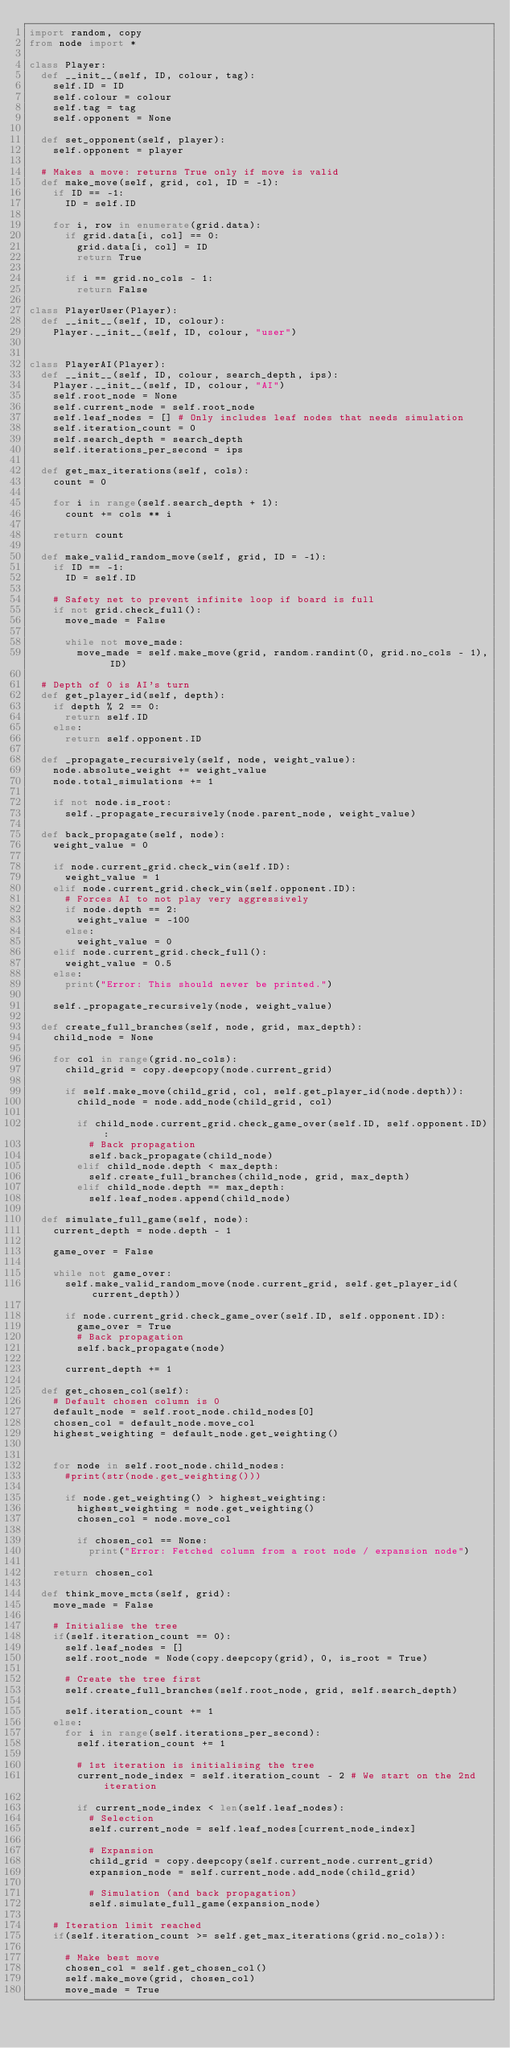<code> <loc_0><loc_0><loc_500><loc_500><_Python_>import random, copy
from node import *

class Player:
	def __init__(self, ID, colour, tag):
		self.ID = ID
		self.colour = colour
		self.tag = tag
		self.opponent = None

	def set_opponent(self, player):
		self.opponent = player

	# Makes a move: returns True only if move is valid
	def make_move(self, grid, col, ID = -1):
		if ID == -1:
			ID = self.ID

		for i, row in enumerate(grid.data):
			if grid.data[i, col] == 0:
				grid.data[i, col] = ID
				return True

			if i == grid.no_cols - 1:
				return False

class PlayerUser(Player):
	def __init__(self, ID, colour):
		Player.__init__(self, ID, colour, "user")


class PlayerAI(Player):
	def __init__(self, ID, colour, search_depth, ips):
		Player.__init__(self, ID, colour, "AI")
		self.root_node = None
		self.current_node = self.root_node
		self.leaf_nodes = [] # Only includes leaf nodes that needs simulation
		self.iteration_count = 0
		self.search_depth = search_depth
		self.iterations_per_second = ips

	def get_max_iterations(self, cols):
		count = 0

		for i in range(self.search_depth + 1):
			count += cols ** i

		return count

	def make_valid_random_move(self, grid, ID = -1):
		if ID == -1:
			ID = self.ID

		# Safety net to prevent infinite loop if board is full
		if not grid.check_full():
			move_made = False

			while not move_made:
				move_made = self.make_move(grid, random.randint(0, grid.no_cols - 1), ID)

	# Depth of 0 is AI's turn
	def get_player_id(self, depth):
		if depth % 2 == 0:
			return self.ID
		else:
			return self.opponent.ID

	def _propagate_recursively(self, node, weight_value):
		node.absolute_weight += weight_value
		node.total_simulations += 1

		if not node.is_root:
			self._propagate_recursively(node.parent_node, weight_value)

	def back_propagate(self, node):
		weight_value = 0

		if node.current_grid.check_win(self.ID):
			weight_value = 1
		elif node.current_grid.check_win(self.opponent.ID):
			# Forces AI to not play very aggressively
			if node.depth == 2:
				weight_value = -100
			else:
				weight_value = 0
		elif node.current_grid.check_full():
			weight_value = 0.5
		else:
			print("Error: This should never be printed.")

		self._propagate_recursively(node, weight_value)

	def create_full_branches(self, node, grid, max_depth):
		child_node = None

		for col in range(grid.no_cols):
			child_grid = copy.deepcopy(node.current_grid)

			if self.make_move(child_grid, col, self.get_player_id(node.depth)):
				child_node = node.add_node(child_grid, col)

				if child_node.current_grid.check_game_over(self.ID, self.opponent.ID):
					# Back propagation
					self.back_propagate(child_node)
				elif child_node.depth < max_depth:
					self.create_full_branches(child_node, grid, max_depth)
				elif child_node.depth == max_depth:
					self.leaf_nodes.append(child_node)

	def simulate_full_game(self, node):
		current_depth = node.depth - 1

		game_over = False

		while not game_over:
			self.make_valid_random_move(node.current_grid, self.get_player_id(current_depth))

			if node.current_grid.check_game_over(self.ID, self.opponent.ID):
				game_over = True
				# Back propagation
				self.back_propagate(node)

			current_depth += 1

	def get_chosen_col(self):
		# Default chosen column is 0
		default_node = self.root_node.child_nodes[0]
		chosen_col = default_node.move_col
		highest_weighting = default_node.get_weighting()


		for node in self.root_node.child_nodes:
			#print(str(node.get_weighting()))

			if node.get_weighting() > highest_weighting:
				highest_weighting = node.get_weighting()
				chosen_col = node.move_col

				if chosen_col == None:
					print("Error: Fetched column from a root node / expansion node")

		return chosen_col

	def think_move_mcts(self, grid):
		move_made = False

		# Initialise the tree
		if(self.iteration_count == 0):
			self.leaf_nodes = []
			self.root_node = Node(copy.deepcopy(grid), 0, is_root = True)

			# Create the tree first
			self.create_full_branches(self.root_node, grid, self.search_depth)

			self.iteration_count += 1
		else:
			for i in range(self.iterations_per_second):
				self.iteration_count += 1

				# 1st iteration is initialising the tree
				current_node_index = self.iteration_count - 2 # We start on the 2nd iteration

				if current_node_index < len(self.leaf_nodes):
					# Selection
					self.current_node = self.leaf_nodes[current_node_index]

					# Expansion
					child_grid = copy.deepcopy(self.current_node.current_grid)
					expansion_node = self.current_node.add_node(child_grid)

					# Simulation (and back propagation)
					self.simulate_full_game(expansion_node)

		# Iteration limit reached
		if(self.iteration_count >= self.get_max_iterations(grid.no_cols)):

			# Make best move
			chosen_col = self.get_chosen_col()
			self.make_move(grid, chosen_col)
			move_made = True</code> 